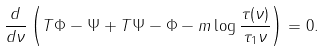<formula> <loc_0><loc_0><loc_500><loc_500>\frac { d } { d \nu } \left ( T \Phi - \Psi + T \Psi - \Phi - m \log \frac { \tau ( \nu ) } { \tau _ { 1 } \nu } \right ) = 0 .</formula> 